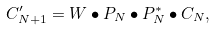<formula> <loc_0><loc_0><loc_500><loc_500>C _ { N + 1 } ^ { \prime } = W \bullet P _ { N } \bullet P _ { N } ^ { * } \bullet C _ { N } ,</formula> 